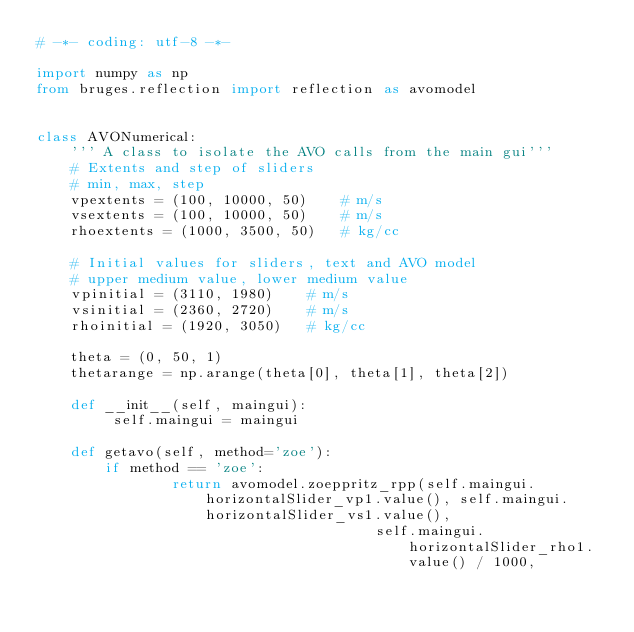Convert code to text. <code><loc_0><loc_0><loc_500><loc_500><_Python_># -*- coding: utf-8 -*-

import numpy as np
from bruges.reflection import reflection as avomodel


class AVONumerical:
    ''' A class to isolate the AVO calls from the main gui'''
    # Extents and step of sliders
    # min, max, step
    vpextents = (100, 10000, 50)    # m/s
    vsextents = (100, 10000, 50)    # m/s
    rhoextents = (1000, 3500, 50)   # kg/cc

    # Initial values for sliders, text and AVO model
    # upper medium value, lower medium value
    vpinitial = (3110, 1980)    # m/s
    vsinitial = (2360, 2720)    # m/s
    rhoinitial = (1920, 3050)   # kg/cc

    theta = (0, 50, 1)
    thetarange = np.arange(theta[0], theta[1], theta[2])

    def __init__(self, maingui):
         self.maingui = maingui

    def getavo(self, method='zoe'):
        if method == 'zoe':
                return avomodel.zoeppritz_rpp(self.maingui.horizontalSlider_vp1.value(), self.maingui.horizontalSlider_vs1.value(),
                                        self.maingui.horizontalSlider_rho1.value() / 1000,</code> 